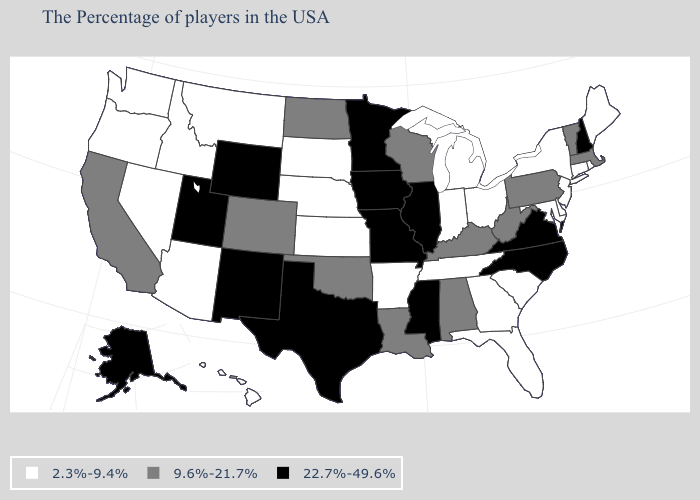What is the value of Rhode Island?
Give a very brief answer. 2.3%-9.4%. Does the first symbol in the legend represent the smallest category?
Answer briefly. Yes. Name the states that have a value in the range 9.6%-21.7%?
Answer briefly. Massachusetts, Vermont, Pennsylvania, West Virginia, Kentucky, Alabama, Wisconsin, Louisiana, Oklahoma, North Dakota, Colorado, California. What is the value of New Mexico?
Keep it brief. 22.7%-49.6%. What is the value of South Dakota?
Give a very brief answer. 2.3%-9.4%. Does Wisconsin have the lowest value in the MidWest?
Write a very short answer. No. What is the value of Rhode Island?
Write a very short answer. 2.3%-9.4%. What is the value of Missouri?
Concise answer only. 22.7%-49.6%. What is the highest value in the West ?
Answer briefly. 22.7%-49.6%. Among the states that border Connecticut , does Rhode Island have the highest value?
Be succinct. No. Name the states that have a value in the range 22.7%-49.6%?
Short answer required. New Hampshire, Virginia, North Carolina, Illinois, Mississippi, Missouri, Minnesota, Iowa, Texas, Wyoming, New Mexico, Utah, Alaska. What is the highest value in states that border Utah?
Write a very short answer. 22.7%-49.6%. What is the lowest value in states that border Nevada?
Answer briefly. 2.3%-9.4%. How many symbols are there in the legend?
Give a very brief answer. 3. What is the value of North Dakota?
Write a very short answer. 9.6%-21.7%. 